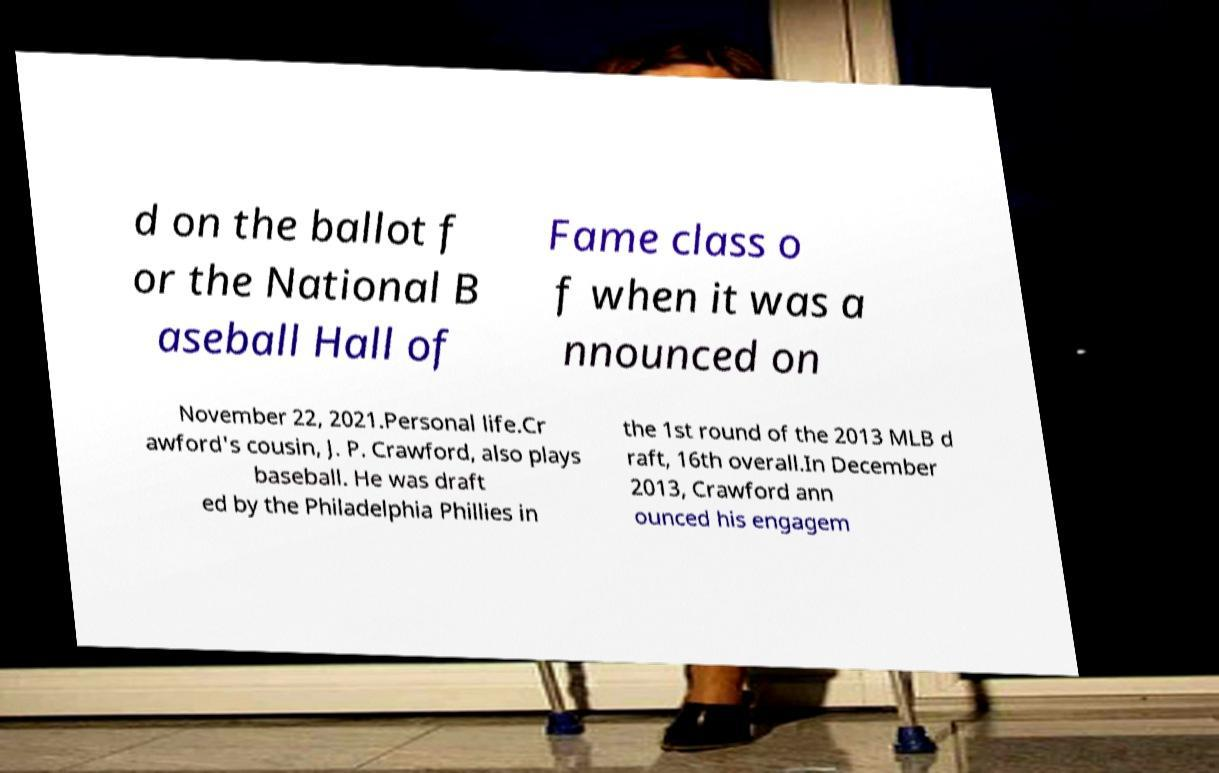What messages or text are displayed in this image? I need them in a readable, typed format. d on the ballot f or the National B aseball Hall of Fame class o f when it was a nnounced on November 22, 2021.Personal life.Cr awford's cousin, J. P. Crawford, also plays baseball. He was draft ed by the Philadelphia Phillies in the 1st round of the 2013 MLB d raft, 16th overall.In December 2013, Crawford ann ounced his engagem 